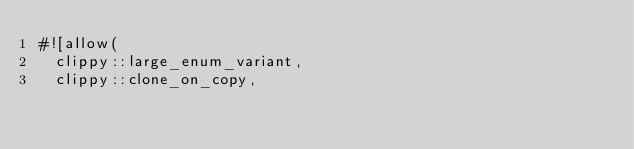Convert code to text. <code><loc_0><loc_0><loc_500><loc_500><_Rust_>#![allow(
	clippy::large_enum_variant,
	clippy::clone_on_copy,</code> 